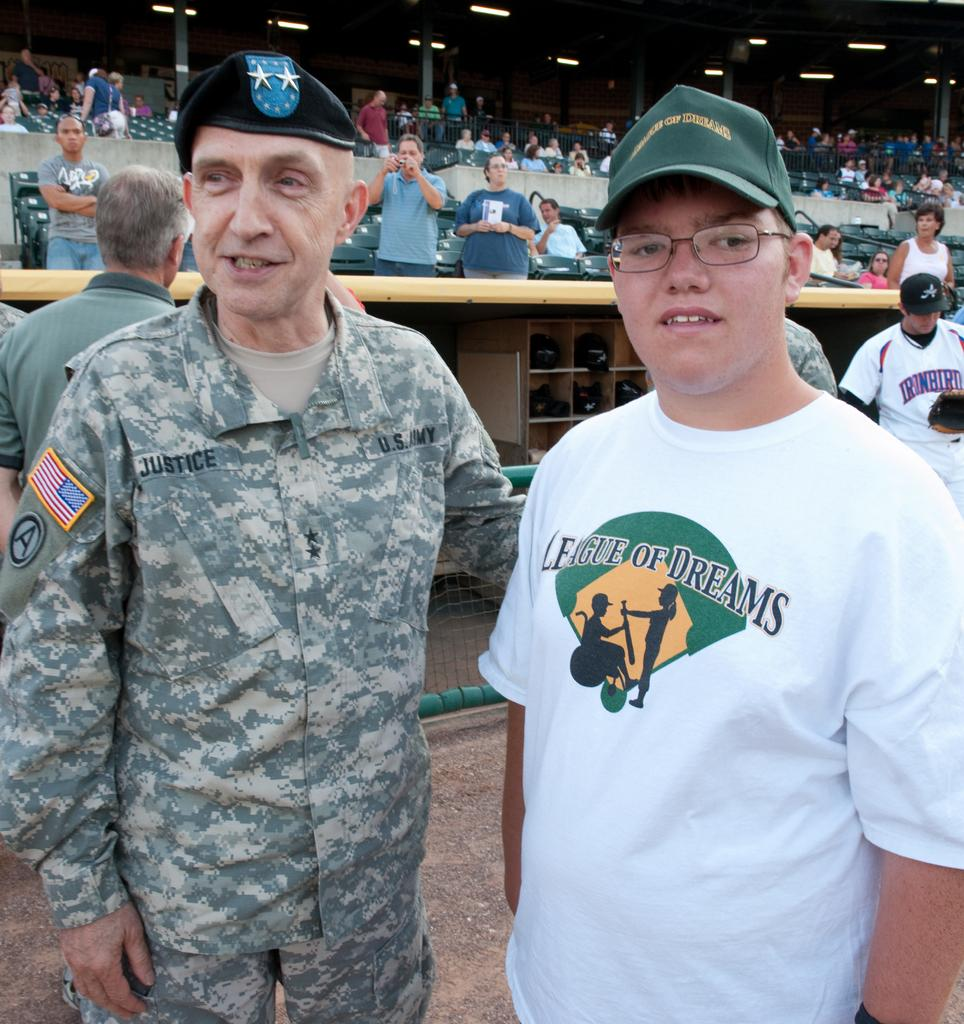<image>
Summarize the visual content of the image. Two mean with one wearing a League of dreams shirt 